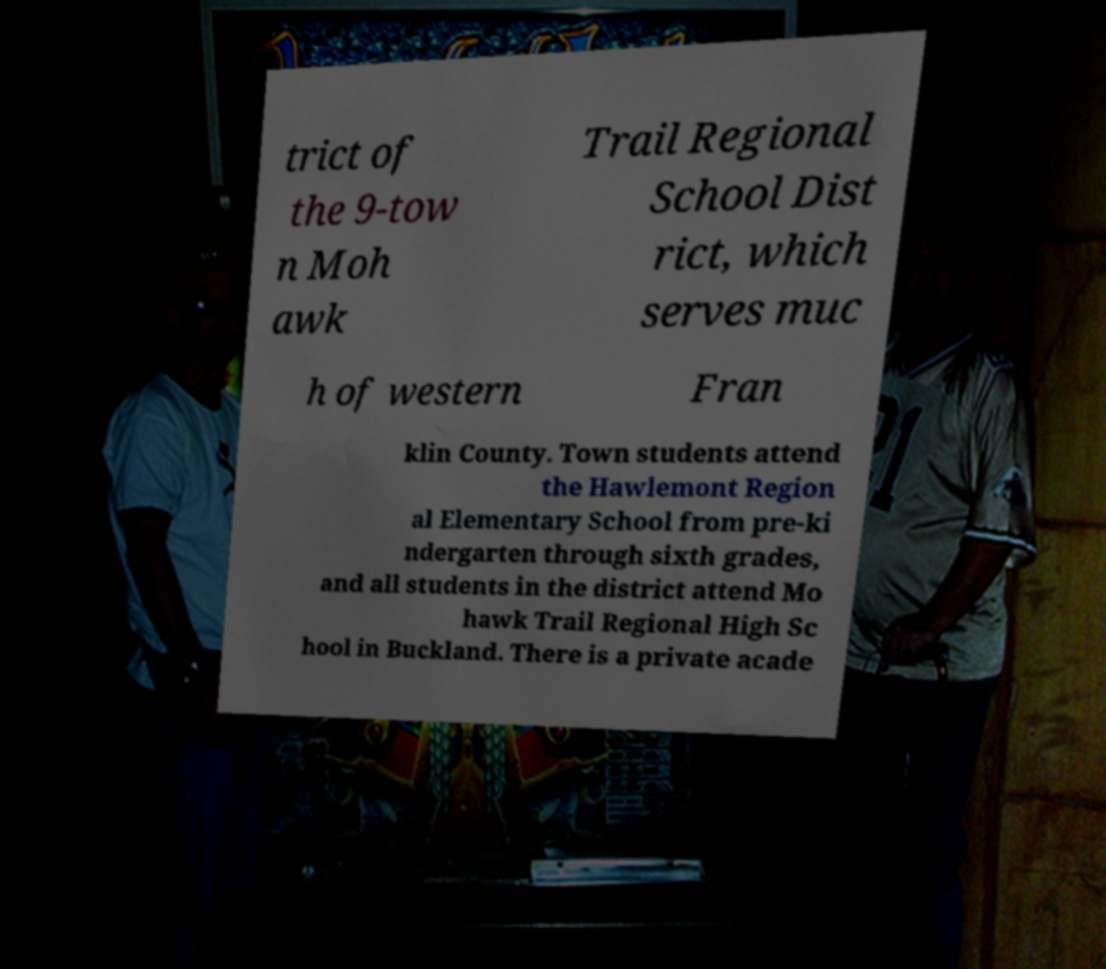Could you assist in decoding the text presented in this image and type it out clearly? trict of the 9-tow n Moh awk Trail Regional School Dist rict, which serves muc h of western Fran klin County. Town students attend the Hawlemont Region al Elementary School from pre-ki ndergarten through sixth grades, and all students in the district attend Mo hawk Trail Regional High Sc hool in Buckland. There is a private acade 